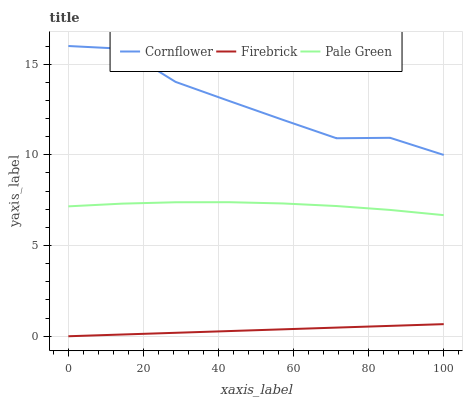Does Firebrick have the minimum area under the curve?
Answer yes or no. Yes. Does Cornflower have the maximum area under the curve?
Answer yes or no. Yes. Does Pale Green have the minimum area under the curve?
Answer yes or no. No. Does Pale Green have the maximum area under the curve?
Answer yes or no. No. Is Firebrick the smoothest?
Answer yes or no. Yes. Is Cornflower the roughest?
Answer yes or no. Yes. Is Pale Green the smoothest?
Answer yes or no. No. Is Pale Green the roughest?
Answer yes or no. No. Does Pale Green have the lowest value?
Answer yes or no. No. Does Cornflower have the highest value?
Answer yes or no. Yes. Does Pale Green have the highest value?
Answer yes or no. No. Is Firebrick less than Cornflower?
Answer yes or no. Yes. Is Cornflower greater than Pale Green?
Answer yes or no. Yes. Does Firebrick intersect Cornflower?
Answer yes or no. No. 